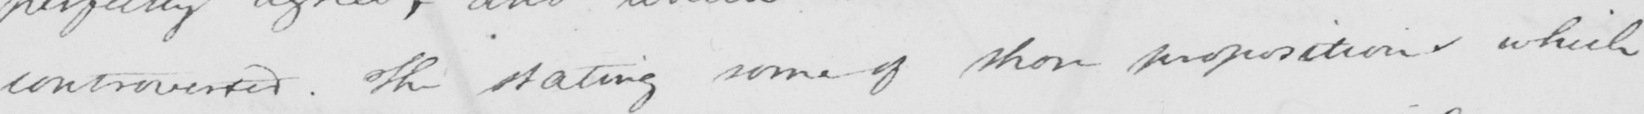Can you tell me what this handwritten text says? controverted . The stating some of those propositions which 